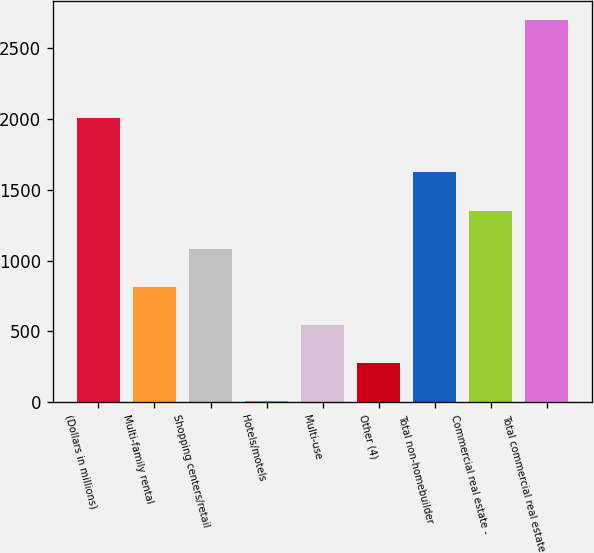Convert chart to OTSL. <chart><loc_0><loc_0><loc_500><loc_500><bar_chart><fcel>(Dollars in millions)<fcel>Multi-family rental<fcel>Shopping centers/retail<fcel>Hotels/motels<fcel>Multi-use<fcel>Other (4)<fcel>Total non-homebuilder<fcel>Commercial real estate -<fcel>Total commercial real estate<nl><fcel>2009<fcel>814.1<fcel>1083.8<fcel>5<fcel>544.4<fcel>274.7<fcel>1623.2<fcel>1353.5<fcel>2702<nl></chart> 